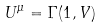<formula> <loc_0><loc_0><loc_500><loc_500>U ^ { \mu } = \Gamma ( 1 , V )</formula> 